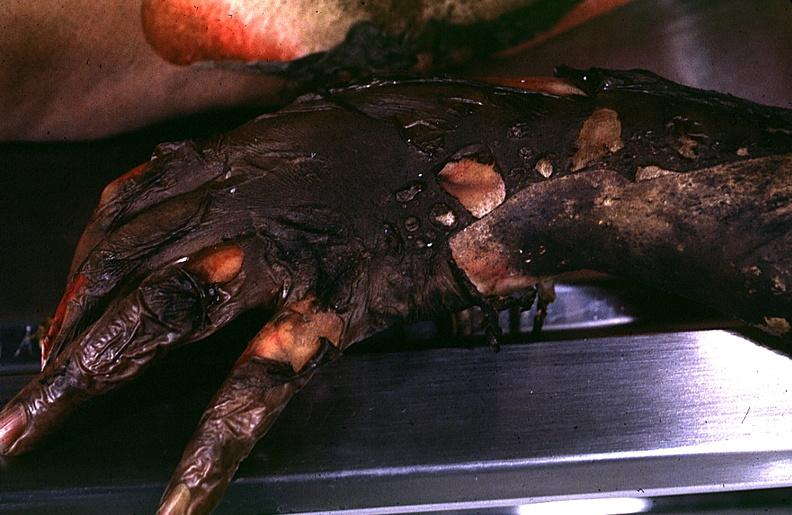what does this image show?
Answer the question using a single word or phrase. Thermal burn 